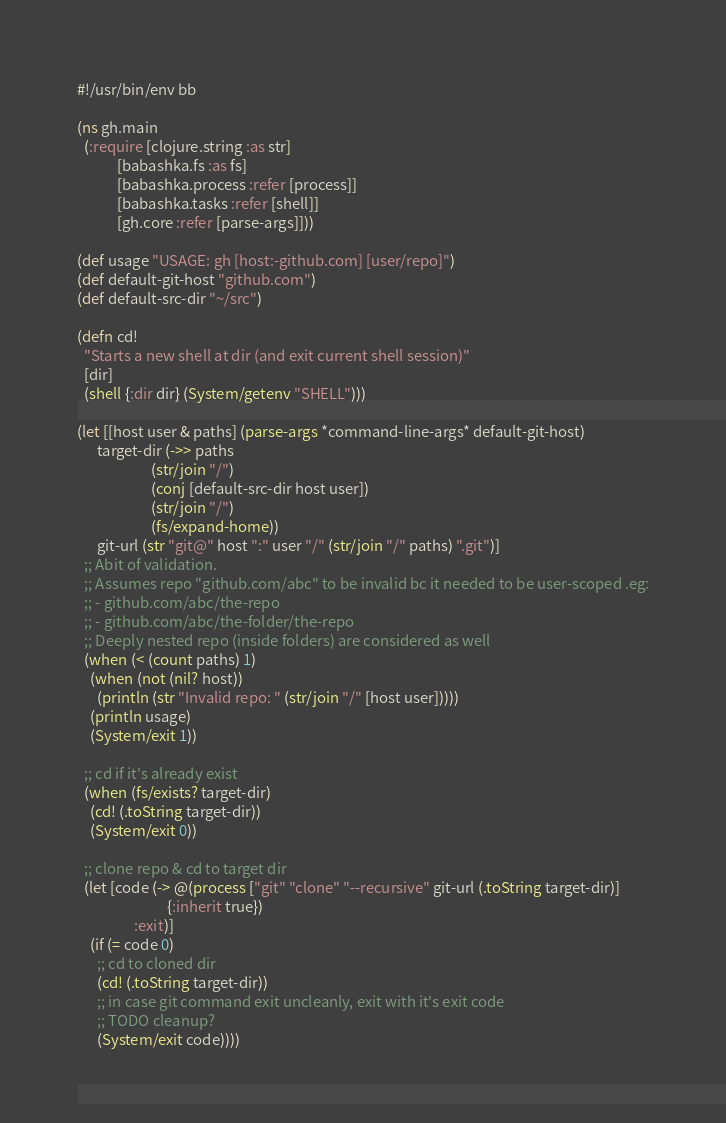Convert code to text. <code><loc_0><loc_0><loc_500><loc_500><_Clojure_>#!/usr/bin/env bb

(ns gh.main
  (:require [clojure.string :as str]
            [babashka.fs :as fs]
            [babashka.process :refer [process]]
            [babashka.tasks :refer [shell]]
            [gh.core :refer [parse-args]]))

(def usage "USAGE: gh [host:-github.com] [user/repo]")
(def default-git-host "github.com")
(def default-src-dir "~/src")

(defn cd!
  "Starts a new shell at dir (and exit current shell session)"
  [dir]
  (shell {:dir dir} (System/getenv "SHELL")))

(let [[host user & paths] (parse-args *command-line-args* default-git-host)
      target-dir (->> paths
                      (str/join "/")
                      (conj [default-src-dir host user])
                      (str/join "/")
                      (fs/expand-home))
      git-url (str "git@" host ":" user "/" (str/join "/" paths) ".git")]
  ;; Abit of validation.
  ;; Assumes repo "github.com/abc" to be invalid bc it needed to be user-scoped .eg:
  ;; - github.com/abc/the-repo
  ;; - github.com/abc/the-folder/the-repo
  ;; Deeply nested repo (inside folders) are considered as well
  (when (< (count paths) 1)
    (when (not (nil? host))
      (println (str "Invalid repo: " (str/join "/" [host user]))))
    (println usage)
    (System/exit 1))

  ;; cd if it's already exist
  (when (fs/exists? target-dir)
    (cd! (.toString target-dir))
    (System/exit 0))

  ;; clone repo & cd to target dir
  (let [code (-> @(process ["git" "clone" "--recursive" git-url (.toString target-dir)]
                           {:inherit true})
                 :exit)]
    (if (= code 0)
      ;; cd to cloned dir
      (cd! (.toString target-dir))
      ;; in case git command exit uncleanly, exit with it's exit code
      ;; TODO cleanup?
      (System/exit code))))
</code> 